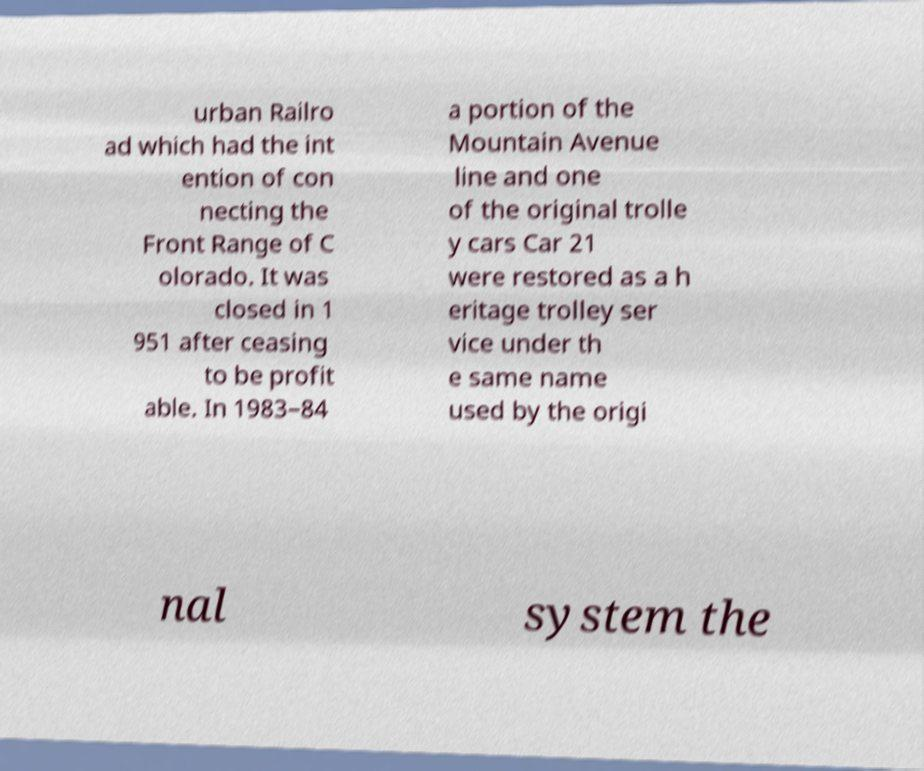Can you accurately transcribe the text from the provided image for me? urban Railro ad which had the int ention of con necting the Front Range of C olorado. It was closed in 1 951 after ceasing to be profit able. In 1983–84 a portion of the Mountain Avenue line and one of the original trolle y cars Car 21 were restored as a h eritage trolley ser vice under th e same name used by the origi nal system the 